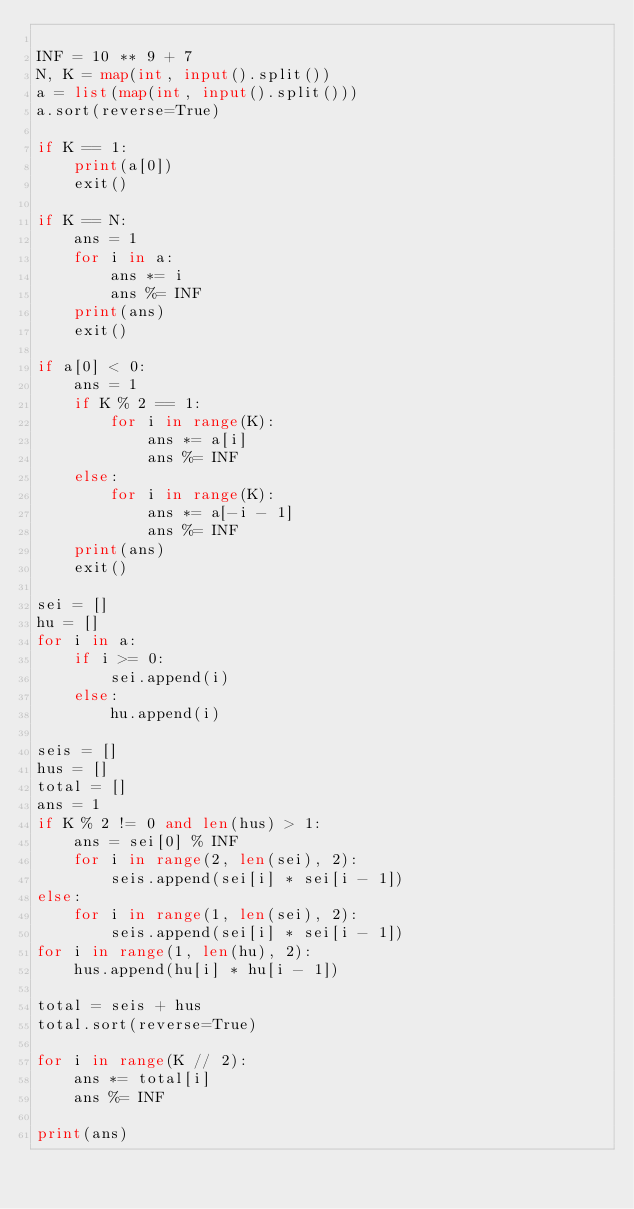Convert code to text. <code><loc_0><loc_0><loc_500><loc_500><_Python_>
INF = 10 ** 9 + 7
N, K = map(int, input().split())
a = list(map(int, input().split()))
a.sort(reverse=True)

if K == 1:
    print(a[0])
    exit()

if K == N:
    ans = 1
    for i in a:
        ans *= i
        ans %= INF
    print(ans)
    exit()

if a[0] < 0:
    ans = 1
    if K % 2 == 1:
        for i in range(K):
            ans *= a[i]
            ans %= INF
    else:
        for i in range(K):
            ans *= a[-i - 1]
            ans %= INF
    print(ans)
    exit()

sei = []
hu = []
for i in a:
    if i >= 0:
        sei.append(i)
    else:
        hu.append(i)

seis = []
hus = []
total = []
ans = 1
if K % 2 != 0 and len(hus) > 1:
    ans = sei[0] % INF
    for i in range(2, len(sei), 2):
        seis.append(sei[i] * sei[i - 1])
else:
    for i in range(1, len(sei), 2):
        seis.append(sei[i] * sei[i - 1])
for i in range(1, len(hu), 2):
    hus.append(hu[i] * hu[i - 1])

total = seis + hus
total.sort(reverse=True)

for i in range(K // 2):
    ans *= total[i]
    ans %= INF

print(ans)
</code> 